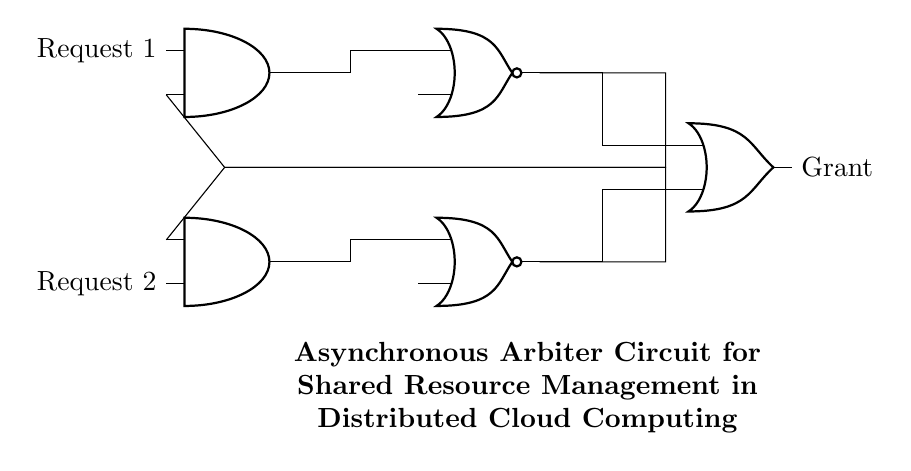What are the main components in this circuit? The circuit includes two AND gates, two NOR gates, and one OR gate, which are identifiable by their symbols in the diagram.
Answer: AND gates, NOR gates, OR gate How many request inputs are there in this arbiter circuit? There are two request inputs labeled as Request 1 and Request 2 connected to the AND gates, indicating the number of inputs needed for arbitration.
Answer: Two What is the purpose of the feedback loops in this circuit? The feedback loops connect the outputs of the NOR gates back to the inputs of the AND gates, which is essential for maintaining the state of the circuit and facilitating the arbitration process.
Answer: To maintain state What is the output signal of this circuit? The output signal of this asynchronous arbiter circuit is labeled as "Grant", which indicates the priority access to the shared resource when one request is granted.
Answer: Grant Which type of circuit is represented in this diagram? The circuit is an asynchronous arbiter circuit, characterized by its use of gates to manage requests for shared resources without requiring a clock signal for synchronization.
Answer: Asynchronous arbiter circuit How do the NOR gates function within the arbiter circuit? The NOR gates receive inputs from the AND gates and generate outputs that help determine which request is granted, playing a critical role in the decision-making process of the arbiter.
Answer: To determine grants 